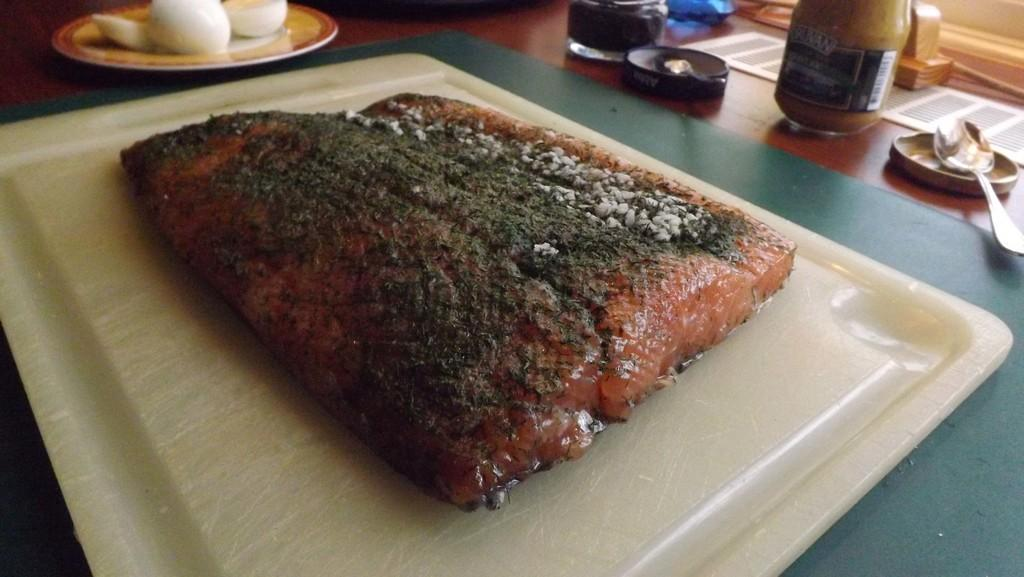What can be seen in the plates in the image? There are food items in plates in the image. Where is the spoon located in the image? The spoon is in the top right corner of the image. What else is located in the top right corner of the image? There is a bottle in the top right corner of the image. How does the food control the spoon in the image? The food does not control the spoon in the image; the spoon is simply placed next to the food. 